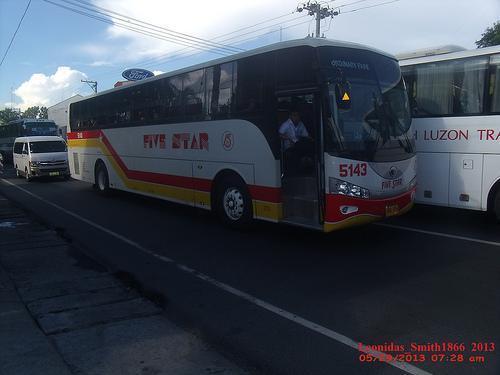How many people are visible?
Give a very brief answer. 1. 